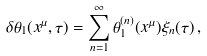Convert formula to latex. <formula><loc_0><loc_0><loc_500><loc_500>\delta \theta _ { 1 } ( x ^ { \mu } , \tau ) = \sum _ { n = 1 } ^ { \infty } \theta _ { 1 } ^ { ( n ) } ( x ^ { \mu } ) \xi _ { n } ( \tau ) \, ,</formula> 